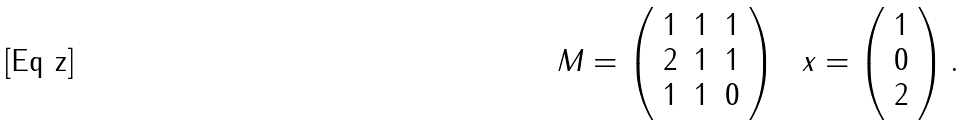<formula> <loc_0><loc_0><loc_500><loc_500>M = \left ( \begin{array} { c c c } 1 & 1 & 1 \\ 2 & 1 & 1 \\ 1 & 1 & 0 \end{array} \right ) \ \ x = \left ( \begin{array} { c } 1 \\ 0 \\ 2 \end{array} \right ) .</formula> 